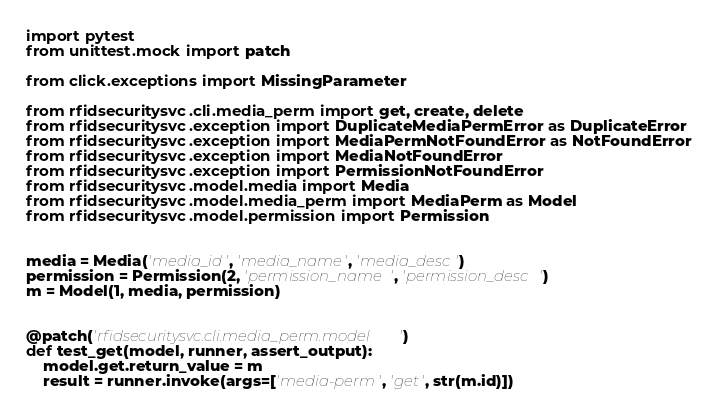<code> <loc_0><loc_0><loc_500><loc_500><_Python_>import pytest
from unittest.mock import patch

from click.exceptions import MissingParameter

from rfidsecuritysvc.cli.media_perm import get, create, delete
from rfidsecuritysvc.exception import DuplicateMediaPermError as DuplicateError
from rfidsecuritysvc.exception import MediaPermNotFoundError as NotFoundError
from rfidsecuritysvc.exception import MediaNotFoundError
from rfidsecuritysvc.exception import PermissionNotFoundError
from rfidsecuritysvc.model.media import Media
from rfidsecuritysvc.model.media_perm import MediaPerm as Model
from rfidsecuritysvc.model.permission import Permission


media = Media('media_id', 'media_name', 'media_desc')
permission = Permission(2, 'permission_name', 'permission_desc')
m = Model(1, media, permission)


@patch('rfidsecuritysvc.cli.media_perm.model')
def test_get(model, runner, assert_output):
    model.get.return_value = m
    result = runner.invoke(args=['media-perm', 'get', str(m.id)])</code> 